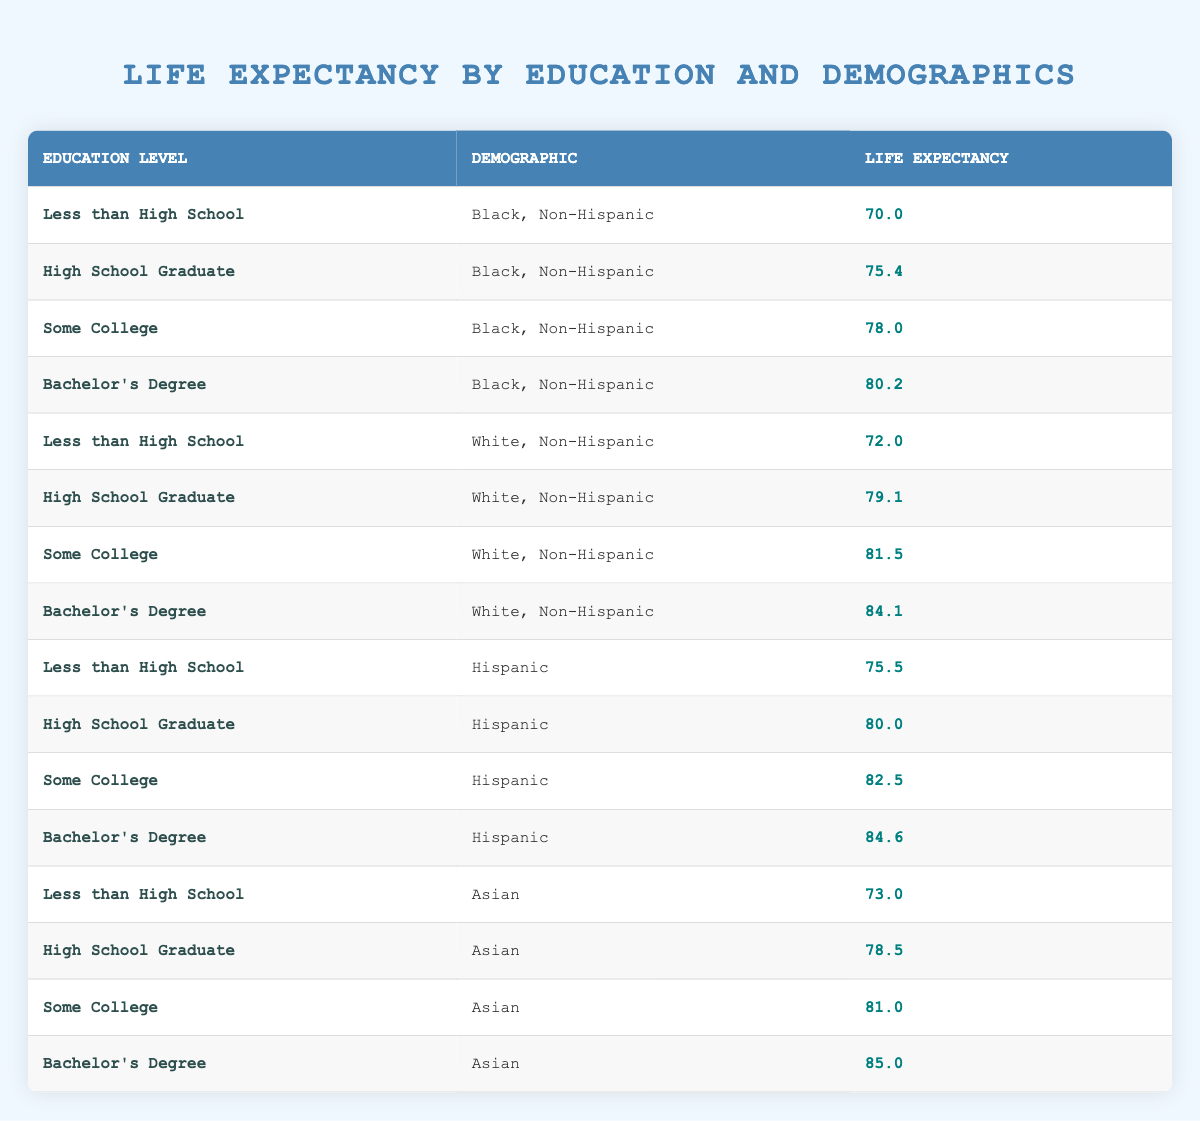What is the life expectancy for individuals with Some College education among Black, Non-Hispanic demographics? According to the table, the life expectancy for individuals with Some College education who identify as Black, Non-Hispanic is 78.0 years. This value can be found directly in the related row of the table.
Answer: 78.0 What is the life expectancy difference between Hispanic individuals with a Bachelor's Degree and those with Less than High School education? For Hispanic individuals, the life expectancy for those with a Bachelor's Degree is 84.6 years and for those with Less than High School is 75.5 years. The difference is calculated as 84.6 - 75.5 = 9.1 years.
Answer: 9.1 Is the life expectancy for White, Non-Hispanic individuals with a Bachelor's Degree higher than that of Asian individuals with Some College education? The life expectancy for White, Non-Hispanic individuals with a Bachelor's Degree is 84.1 years. For Asian individuals with Some College education, it is 81.0 years. Thus, 84.1 is greater than 81.0, confirming that the statement is true.
Answer: Yes What is the average life expectancy of individuals with a High School Graduate education across all demographics? Summing the life expectancies for High School Graduates: 75.4 (Black, Non-Hispanic) + 79.1 (White, Non-Hispanic) + 80.0 (Hispanic) + 78.5 (Asian) gives us a total of 313.0. There are 4 data points, so the average is 313.0 / 4 = 78.25.
Answer: 78.25 Which demographic has the highest life expectancy with a Bachelor's Degree? By examining the life expectancies listed for each demographic with a Bachelor's Degree, we find that Asian individuals have the highest life expectancy at 85.0 years. This can be seen clearly in the respective row of the table.
Answer: 85.0 What is the life expectancy for White, Non-Hispanic individuals with Some College education? The table shows that the life expectancy for White, Non-Hispanic individuals with Some College education is 81.5 years, which can be found in the corresponding row.
Answer: 81.5 Are individuals with a Bachelor's Degree generally expected to live longer than those with Less than High School education across all demographics? Evaluating the data shows that for all demographics, individuals with a Bachelor's Degree have higher life expectancies (80.2 for Black, 84.1 for White, 84.6 for Hispanic, 85.0 for Asian) compared to those with Less than High School education (70.0 for Black, 72.0 for White, 75.5 for Hispanic, 73.0 for Asian). Thus, this statement is true for all cohorts.
Answer: Yes What is the lowest life expectancy among all education levels across all demographics? Looking through the table, the lowest life expectancy recorded is 70.0 years for Black, Non-Hispanic individuals with Less than High School education, making it the minimum in the dataset.
Answer: 70.0 What is the total life expectancy for all demographics with Some College education? We sum the life expectancies for Some College education: 78.0 (Black) + 81.5 (White) + 82.5 (Hispanic) + 81.0 (Asian) = 323.0 years.
Answer: 323.0 